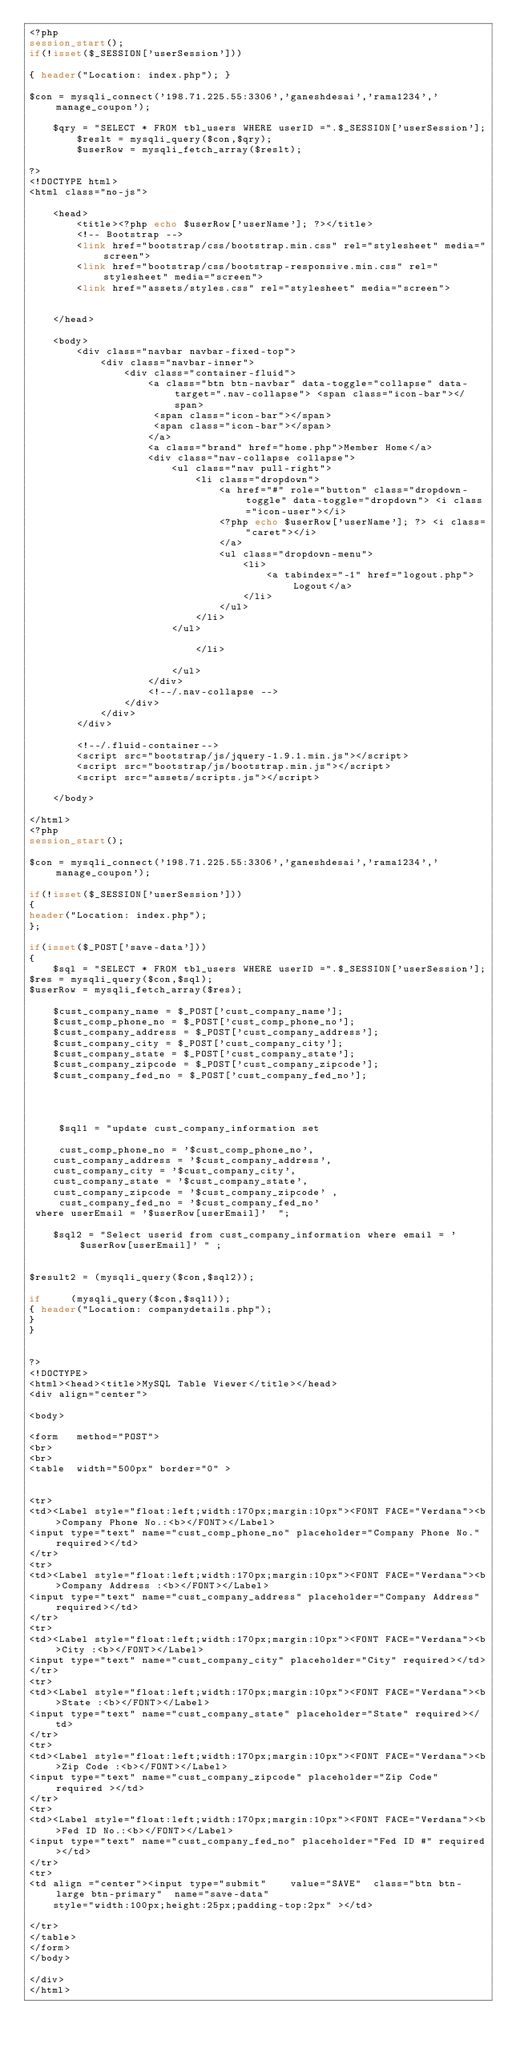<code> <loc_0><loc_0><loc_500><loc_500><_PHP_><?php
session_start();
if(!isset($_SESSION['userSession']))

{ header("Location: index.php"); }

$con = mysqli_connect('198.71.225.55:3306','ganeshdesai','rama1234','manage_coupon');

	$qry = "SELECT * FROM tbl_users WHERE userID =".$_SESSION['userSession'];
        $reslt = mysqli_query($con,$qry);
        $userRow = mysqli_fetch_array($reslt);

?>
<!DOCTYPE html>
<html class="no-js">
    
    <head>
        <title><?php echo $userRow['userName']; ?></title>
        <!-- Bootstrap -->
        <link href="bootstrap/css/bootstrap.min.css" rel="stylesheet" media="screen">
        <link href="bootstrap/css/bootstrap-responsive.min.css" rel="stylesheet" media="screen">
        <link href="assets/styles.css" rel="stylesheet" media="screen">
        
        
    </head>
    
    <body>
        <div class="navbar navbar-fixed-top">
            <div class="navbar-inner">
                <div class="container-fluid">
                    <a class="btn btn-navbar" data-toggle="collapse" data-target=".nav-collapse"> <span class="icon-bar"></span>
                     <span class="icon-bar"></span>
                     <span class="icon-bar"></span>
                    </a>
                    <a class="brand" href="home.php">Member Home</a>
                    <div class="nav-collapse collapse">
                        <ul class="nav pull-right">
                            <li class="dropdown">
                                <a href="#" role="button" class="dropdown-toggle" data-toggle="dropdown"> <i class="icon-user"></i> 
								<?php echo $userRow['userName']; ?> <i class="caret"></i>
                                </a>
                                <ul class="dropdown-menu">
                                    <li>
                                        <a tabindex="-1" href="logout.php">Logout</a>
                                    </li>
                                </ul>
                            </li>
                        </ul>
                        
                            </li>
                            
                        </ul>
                    </div>
                    <!--/.nav-collapse -->
                </div>
            </div>
        </div>
        
        <!--/.fluid-container-->
        <script src="bootstrap/js/jquery-1.9.1.min.js"></script>
        <script src="bootstrap/js/bootstrap.min.js"></script>
        <script src="assets/scripts.js"></script>
        
    </body>

</html>
<?php
session_start();

$con = mysqli_connect('198.71.225.55:3306','ganeshdesai','rama1234','manage_coupon');

if(!isset($_SESSION['userSession']))
{
header("Location: index.php");
};

if(isset($_POST['save-data']))
{
	$sql = "SELECT * FROM tbl_users WHERE userID =".$_SESSION['userSession'];
$res = mysqli_query($con,$sql);
$userRow = mysqli_fetch_array($res);    

	$cust_company_name = $_POST['cust_company_name'];
	$cust_comp_phone_no = $_POST['cust_comp_phone_no'];
	$cust_company_address = $_POST['cust_company_address'];
	$cust_company_city = $_POST['cust_company_city'];
	$cust_company_state = $_POST['cust_company_state'];
	$cust_company_zipcode = $_POST['cust_company_zipcode'];
	$cust_company_fed_no = $_POST['cust_company_fed_no'];
	
	
	
	
	 $sql1 = "update cust_company_information set  
	  
	 cust_comp_phone_no = '$cust_comp_phone_no', 
	cust_company_address = '$cust_company_address',
	cust_company_city = '$cust_company_city', 
	cust_company_state = '$cust_company_state', 
	cust_company_zipcode = '$cust_company_zipcode' , 
	 cust_company_fed_no = '$cust_company_fed_no'
 where userEmail = '$userRow[userEmail]'  ";
	
	$sql2 = "Select userid from cust_company_information where email = '$userRow[userEmail]' " ;


$result2 = (mysqli_query($con,$sql2));

if     (mysqli_query($con,$sql1));
{ header("Location: companydetails.php");
}
}


?>
<!DOCTYPE>
<html><head><title>MySQL Table Viewer</title></head>
<div align="center">

<body>	
	
<form   method="POST">
<br>
<br>
<table  width="500px" border="0" >


<tr>				
<td><Label style="float:left;width:170px;margin:10px"><FONT FACE="Verdana"><b>Company Phone No.:<b></FONT></Label>
<input type="text" name="cust_comp_phone_no" placeholder="Company Phone No." required></td>
</tr>
<tr>				
<td><Label style="float:left;width:170px;margin:10px"><FONT FACE="Verdana"><b>Company Address :<b></FONT></Label>
<input type="text" name="cust_company_address" placeholder="Company Address" required></td>
</tr>
<tr>				
<td><Label style="float:left;width:170px;margin:10px"><FONT FACE="Verdana"><b>City :<b></FONT></Label>
<input type="text" name="cust_company_city" placeholder="City" required></td>
</tr>
<tr>
<td><Label style="float:left;width:170px;margin:10px"><FONT FACE="Verdana"><b>State :<b></FONT></Label>
<input type="text" name="cust_company_state" placeholder="State" required></td>
</tr>
<tr>
<td><Label style="float:left;width:170px;margin:10px"><FONT FACE="Verdana"><b>Zip Code :<b></FONT></Label>
<input type="text" name="cust_company_zipcode" placeholder="Zip Code" required ></td>
</tr>
<tr>
<td><Label style="float:left;width:170px;margin:10px"><FONT FACE="Verdana"><b>Fed ID No.:<b></FONT></Label>
<input type="text" name="cust_company_fed_no" placeholder="Fed ID #" required></td>
</tr>
<tr>
<td align ="center"><input type="submit" 	value="SAVE"  class="btn btn-large btn-primary"  name="save-data" 
	style="width:100px;height:25px;padding-top:2px" ></td>

</tr>
</table>
</form>
</body>

</div>
</html>





</code> 